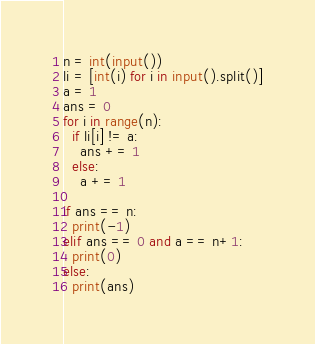Convert code to text. <code><loc_0><loc_0><loc_500><loc_500><_Python_>n = int(input())
li = [int(i) for i in input().split()]
a = 1
ans = 0
for i in range(n):
  if li[i] != a:
    ans += 1
  else:
    a += 1

if ans == n:
  print(-1)
elif ans == 0 and a == n+1:
  print(0)
else:
  print(ans)</code> 